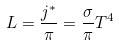Convert formula to latex. <formula><loc_0><loc_0><loc_500><loc_500>L = \frac { j ^ { * } } { \pi } = \frac { \sigma } { \pi } T ^ { 4 }</formula> 